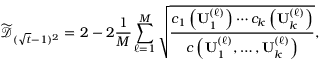Convert formula to latex. <formula><loc_0><loc_0><loc_500><loc_500>\widetilde { \mathcal { D } } _ { ( \sqrt { t } - 1 ) ^ { 2 } } = 2 - 2 \frac { 1 } { M } \sum _ { \ell = 1 } ^ { M } \sqrt { \frac { c _ { 1 } \left ( U _ { 1 } ^ { ( \ell ) } \right ) \cdots c _ { k } \left ( U _ { k } ^ { ( \ell ) } \right ) } { c \left ( U _ { 1 } ^ { ( \ell ) } , \dots , U _ { k } ^ { ( \ell ) } \right ) } } ,</formula> 